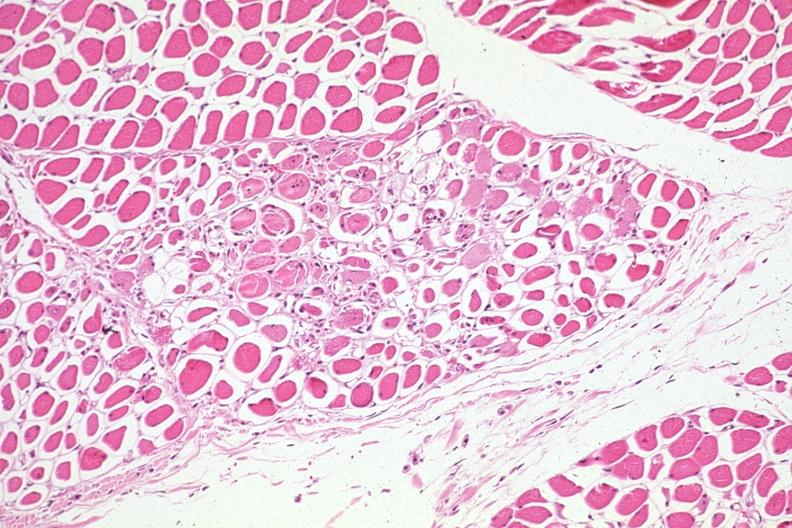s stress present?
Answer the question using a single word or phrase. No 